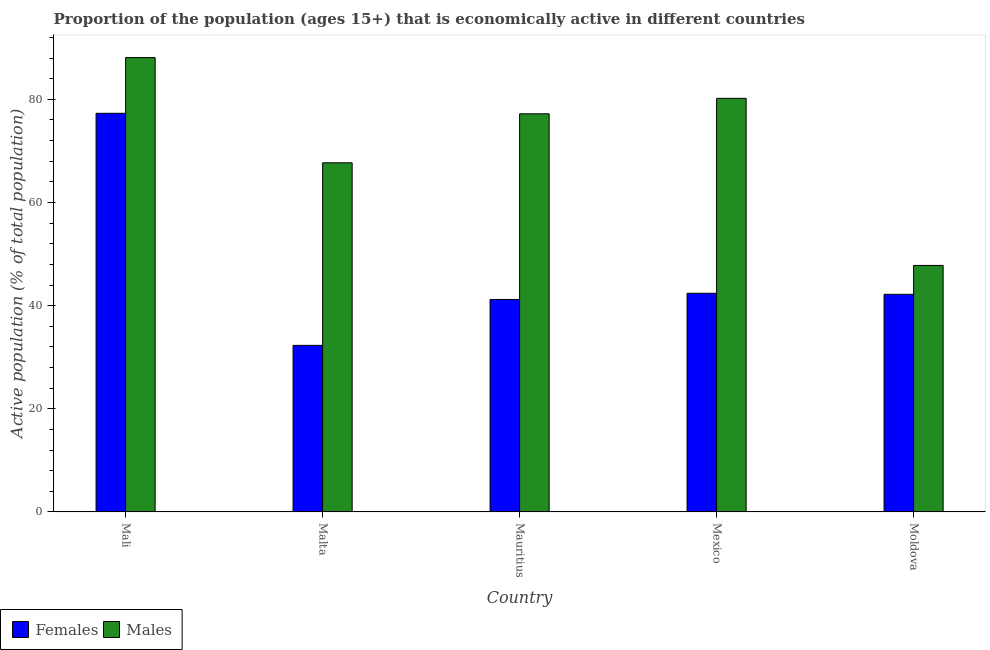How many different coloured bars are there?
Make the answer very short. 2. Are the number of bars on each tick of the X-axis equal?
Offer a very short reply. Yes. How many bars are there on the 4th tick from the left?
Give a very brief answer. 2. How many bars are there on the 2nd tick from the right?
Provide a short and direct response. 2. What is the label of the 5th group of bars from the left?
Your response must be concise. Moldova. In how many cases, is the number of bars for a given country not equal to the number of legend labels?
Your answer should be very brief. 0. What is the percentage of economically active male population in Mexico?
Your answer should be very brief. 80.2. Across all countries, what is the maximum percentage of economically active female population?
Your answer should be compact. 77.3. Across all countries, what is the minimum percentage of economically active male population?
Provide a succinct answer. 47.8. In which country was the percentage of economically active male population maximum?
Provide a short and direct response. Mali. In which country was the percentage of economically active male population minimum?
Your response must be concise. Moldova. What is the total percentage of economically active male population in the graph?
Keep it short and to the point. 361. What is the difference between the percentage of economically active female population in Mali and that in Mauritius?
Your answer should be very brief. 36.1. What is the difference between the percentage of economically active male population in Moldova and the percentage of economically active female population in Mauritius?
Provide a succinct answer. 6.6. What is the average percentage of economically active female population per country?
Ensure brevity in your answer.  47.08. What is the difference between the percentage of economically active male population and percentage of economically active female population in Mexico?
Provide a short and direct response. 37.8. What is the ratio of the percentage of economically active male population in Malta to that in Moldova?
Your answer should be very brief. 1.42. Is the difference between the percentage of economically active female population in Mali and Mauritius greater than the difference between the percentage of economically active male population in Mali and Mauritius?
Offer a very short reply. Yes. What is the difference between the highest and the second highest percentage of economically active female population?
Make the answer very short. 34.9. What is the difference between the highest and the lowest percentage of economically active female population?
Offer a very short reply. 45. Is the sum of the percentage of economically active female population in Mali and Malta greater than the maximum percentage of economically active male population across all countries?
Ensure brevity in your answer.  Yes. What does the 1st bar from the left in Mali represents?
Offer a very short reply. Females. What does the 1st bar from the right in Mexico represents?
Your response must be concise. Males. How many bars are there?
Offer a terse response. 10. Are all the bars in the graph horizontal?
Provide a short and direct response. No. How many countries are there in the graph?
Ensure brevity in your answer.  5. What is the difference between two consecutive major ticks on the Y-axis?
Make the answer very short. 20. Are the values on the major ticks of Y-axis written in scientific E-notation?
Your answer should be compact. No. Where does the legend appear in the graph?
Make the answer very short. Bottom left. What is the title of the graph?
Provide a succinct answer. Proportion of the population (ages 15+) that is economically active in different countries. Does "Food and tobacco" appear as one of the legend labels in the graph?
Ensure brevity in your answer.  No. What is the label or title of the Y-axis?
Your answer should be compact. Active population (% of total population). What is the Active population (% of total population) of Females in Mali?
Provide a succinct answer. 77.3. What is the Active population (% of total population) in Males in Mali?
Keep it short and to the point. 88.1. What is the Active population (% of total population) in Females in Malta?
Provide a succinct answer. 32.3. What is the Active population (% of total population) in Males in Malta?
Your answer should be compact. 67.7. What is the Active population (% of total population) of Females in Mauritius?
Provide a succinct answer. 41.2. What is the Active population (% of total population) of Males in Mauritius?
Offer a terse response. 77.2. What is the Active population (% of total population) in Females in Mexico?
Offer a very short reply. 42.4. What is the Active population (% of total population) of Males in Mexico?
Your response must be concise. 80.2. What is the Active population (% of total population) in Females in Moldova?
Offer a terse response. 42.2. What is the Active population (% of total population) in Males in Moldova?
Ensure brevity in your answer.  47.8. Across all countries, what is the maximum Active population (% of total population) of Females?
Your answer should be very brief. 77.3. Across all countries, what is the maximum Active population (% of total population) of Males?
Your answer should be very brief. 88.1. Across all countries, what is the minimum Active population (% of total population) in Females?
Offer a terse response. 32.3. Across all countries, what is the minimum Active population (% of total population) of Males?
Your answer should be very brief. 47.8. What is the total Active population (% of total population) of Females in the graph?
Offer a terse response. 235.4. What is the total Active population (% of total population) of Males in the graph?
Provide a succinct answer. 361. What is the difference between the Active population (% of total population) in Females in Mali and that in Malta?
Provide a succinct answer. 45. What is the difference between the Active population (% of total population) in Males in Mali and that in Malta?
Provide a short and direct response. 20.4. What is the difference between the Active population (% of total population) of Females in Mali and that in Mauritius?
Offer a very short reply. 36.1. What is the difference between the Active population (% of total population) of Males in Mali and that in Mauritius?
Your response must be concise. 10.9. What is the difference between the Active population (% of total population) in Females in Mali and that in Mexico?
Ensure brevity in your answer.  34.9. What is the difference between the Active population (% of total population) of Males in Mali and that in Mexico?
Your answer should be very brief. 7.9. What is the difference between the Active population (% of total population) in Females in Mali and that in Moldova?
Keep it short and to the point. 35.1. What is the difference between the Active population (% of total population) in Males in Mali and that in Moldova?
Make the answer very short. 40.3. What is the difference between the Active population (% of total population) of Females in Malta and that in Mauritius?
Your answer should be very brief. -8.9. What is the difference between the Active population (% of total population) in Males in Malta and that in Mauritius?
Make the answer very short. -9.5. What is the difference between the Active population (% of total population) of Females in Malta and that in Mexico?
Your answer should be very brief. -10.1. What is the difference between the Active population (% of total population) in Males in Malta and that in Mexico?
Provide a short and direct response. -12.5. What is the difference between the Active population (% of total population) in Males in Malta and that in Moldova?
Provide a succinct answer. 19.9. What is the difference between the Active population (% of total population) in Females in Mauritius and that in Mexico?
Your answer should be compact. -1.2. What is the difference between the Active population (% of total population) in Males in Mauritius and that in Mexico?
Give a very brief answer. -3. What is the difference between the Active population (% of total population) of Females in Mauritius and that in Moldova?
Offer a terse response. -1. What is the difference between the Active population (% of total population) in Males in Mauritius and that in Moldova?
Your response must be concise. 29.4. What is the difference between the Active population (% of total population) in Females in Mexico and that in Moldova?
Ensure brevity in your answer.  0.2. What is the difference between the Active population (% of total population) of Males in Mexico and that in Moldova?
Your answer should be very brief. 32.4. What is the difference between the Active population (% of total population) in Females in Mali and the Active population (% of total population) in Males in Malta?
Your answer should be compact. 9.6. What is the difference between the Active population (% of total population) of Females in Mali and the Active population (% of total population) of Males in Mauritius?
Ensure brevity in your answer.  0.1. What is the difference between the Active population (% of total population) of Females in Mali and the Active population (% of total population) of Males in Moldova?
Offer a terse response. 29.5. What is the difference between the Active population (% of total population) in Females in Malta and the Active population (% of total population) in Males in Mauritius?
Your response must be concise. -44.9. What is the difference between the Active population (% of total population) of Females in Malta and the Active population (% of total population) of Males in Mexico?
Keep it short and to the point. -47.9. What is the difference between the Active population (% of total population) of Females in Malta and the Active population (% of total population) of Males in Moldova?
Give a very brief answer. -15.5. What is the difference between the Active population (% of total population) in Females in Mauritius and the Active population (% of total population) in Males in Mexico?
Offer a terse response. -39. What is the difference between the Active population (% of total population) of Females in Mauritius and the Active population (% of total population) of Males in Moldova?
Ensure brevity in your answer.  -6.6. What is the difference between the Active population (% of total population) in Females in Mexico and the Active population (% of total population) in Males in Moldova?
Provide a succinct answer. -5.4. What is the average Active population (% of total population) in Females per country?
Make the answer very short. 47.08. What is the average Active population (% of total population) of Males per country?
Keep it short and to the point. 72.2. What is the difference between the Active population (% of total population) in Females and Active population (% of total population) in Males in Mali?
Make the answer very short. -10.8. What is the difference between the Active population (% of total population) of Females and Active population (% of total population) of Males in Malta?
Ensure brevity in your answer.  -35.4. What is the difference between the Active population (% of total population) in Females and Active population (% of total population) in Males in Mauritius?
Ensure brevity in your answer.  -36. What is the difference between the Active population (% of total population) in Females and Active population (% of total population) in Males in Mexico?
Keep it short and to the point. -37.8. What is the ratio of the Active population (% of total population) in Females in Mali to that in Malta?
Ensure brevity in your answer.  2.39. What is the ratio of the Active population (% of total population) in Males in Mali to that in Malta?
Your answer should be compact. 1.3. What is the ratio of the Active population (% of total population) in Females in Mali to that in Mauritius?
Ensure brevity in your answer.  1.88. What is the ratio of the Active population (% of total population) of Males in Mali to that in Mauritius?
Your answer should be very brief. 1.14. What is the ratio of the Active population (% of total population) in Females in Mali to that in Mexico?
Your answer should be compact. 1.82. What is the ratio of the Active population (% of total population) of Males in Mali to that in Mexico?
Your answer should be very brief. 1.1. What is the ratio of the Active population (% of total population) of Females in Mali to that in Moldova?
Give a very brief answer. 1.83. What is the ratio of the Active population (% of total population) in Males in Mali to that in Moldova?
Your response must be concise. 1.84. What is the ratio of the Active population (% of total population) of Females in Malta to that in Mauritius?
Provide a short and direct response. 0.78. What is the ratio of the Active population (% of total population) of Males in Malta to that in Mauritius?
Your answer should be compact. 0.88. What is the ratio of the Active population (% of total population) of Females in Malta to that in Mexico?
Provide a short and direct response. 0.76. What is the ratio of the Active population (% of total population) of Males in Malta to that in Mexico?
Ensure brevity in your answer.  0.84. What is the ratio of the Active population (% of total population) in Females in Malta to that in Moldova?
Make the answer very short. 0.77. What is the ratio of the Active population (% of total population) in Males in Malta to that in Moldova?
Provide a short and direct response. 1.42. What is the ratio of the Active population (% of total population) of Females in Mauritius to that in Mexico?
Your response must be concise. 0.97. What is the ratio of the Active population (% of total population) in Males in Mauritius to that in Mexico?
Provide a succinct answer. 0.96. What is the ratio of the Active population (% of total population) in Females in Mauritius to that in Moldova?
Keep it short and to the point. 0.98. What is the ratio of the Active population (% of total population) in Males in Mauritius to that in Moldova?
Your answer should be very brief. 1.62. What is the ratio of the Active population (% of total population) in Females in Mexico to that in Moldova?
Make the answer very short. 1. What is the ratio of the Active population (% of total population) of Males in Mexico to that in Moldova?
Offer a terse response. 1.68. What is the difference between the highest and the second highest Active population (% of total population) in Females?
Provide a short and direct response. 34.9. What is the difference between the highest and the second highest Active population (% of total population) of Males?
Keep it short and to the point. 7.9. What is the difference between the highest and the lowest Active population (% of total population) of Males?
Ensure brevity in your answer.  40.3. 